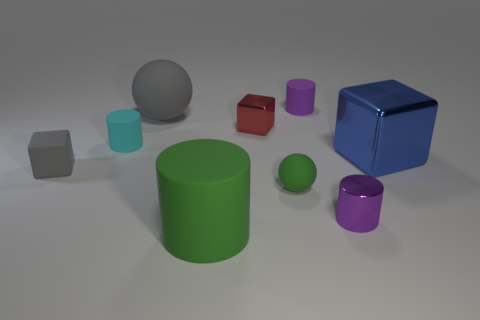Subtract all small blocks. How many blocks are left? 1 Subtract all gray cubes. How many purple cylinders are left? 2 Add 1 green metal spheres. How many objects exist? 10 Subtract 2 cylinders. How many cylinders are left? 2 Subtract all green cylinders. How many cylinders are left? 3 Subtract all blue cylinders. Subtract all gray balls. How many cylinders are left? 4 Subtract all spheres. How many objects are left? 7 Subtract 1 blue blocks. How many objects are left? 8 Subtract all tiny brown cubes. Subtract all gray balls. How many objects are left? 8 Add 6 blue metal things. How many blue metal things are left? 7 